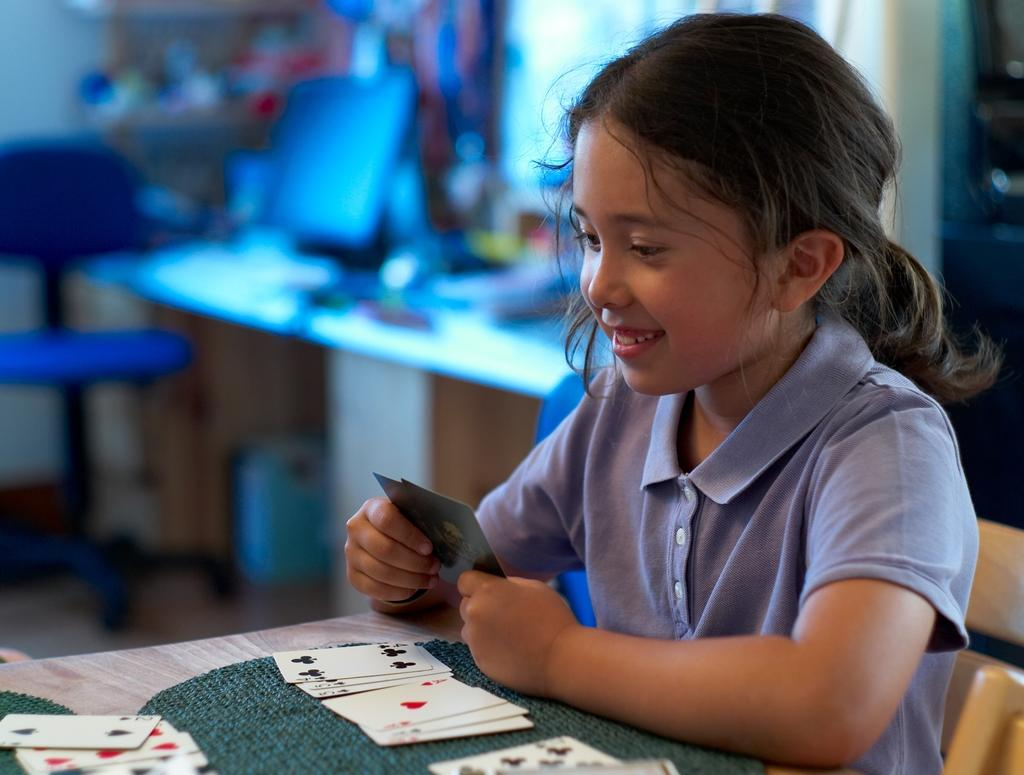Who is the main subject in the image? There is a girl in the image. What is the girl doing in the image? The girl is sitting on a chair and smiling. What is on the table in the image? There are cards on the table. What electronic device is present in the image? There is a monitor in the image. What type of surface is visible in the image? There is a floor visible in the image. Where is the pail located in the image? There is no pail present in the image. How many brothers does the girl have in the image? The image does not provide information about the girl's brothers. 